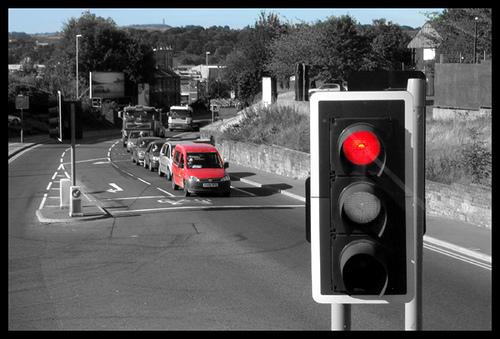What color is the light?
Keep it brief. Red. Is this a traffic jam?
Keep it brief. No. Why is the traffic stopped?
Quick response, please. Red light. How many lights are there?
Concise answer only. 3. 